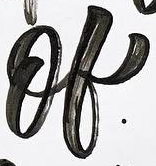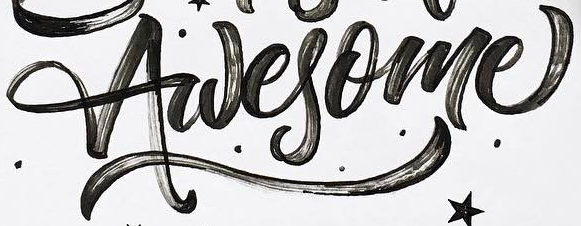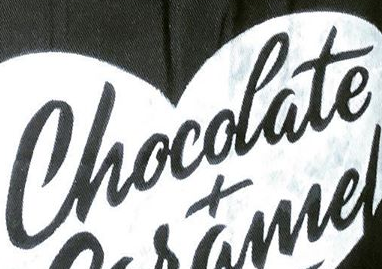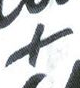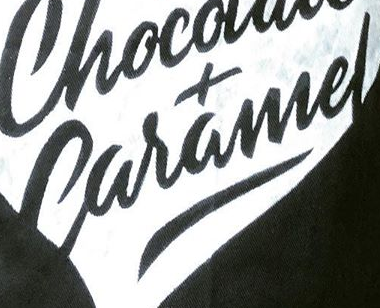What text is displayed in these images sequentially, separated by a semicolon? of; Awesome; Chocolate; +; Caramel 